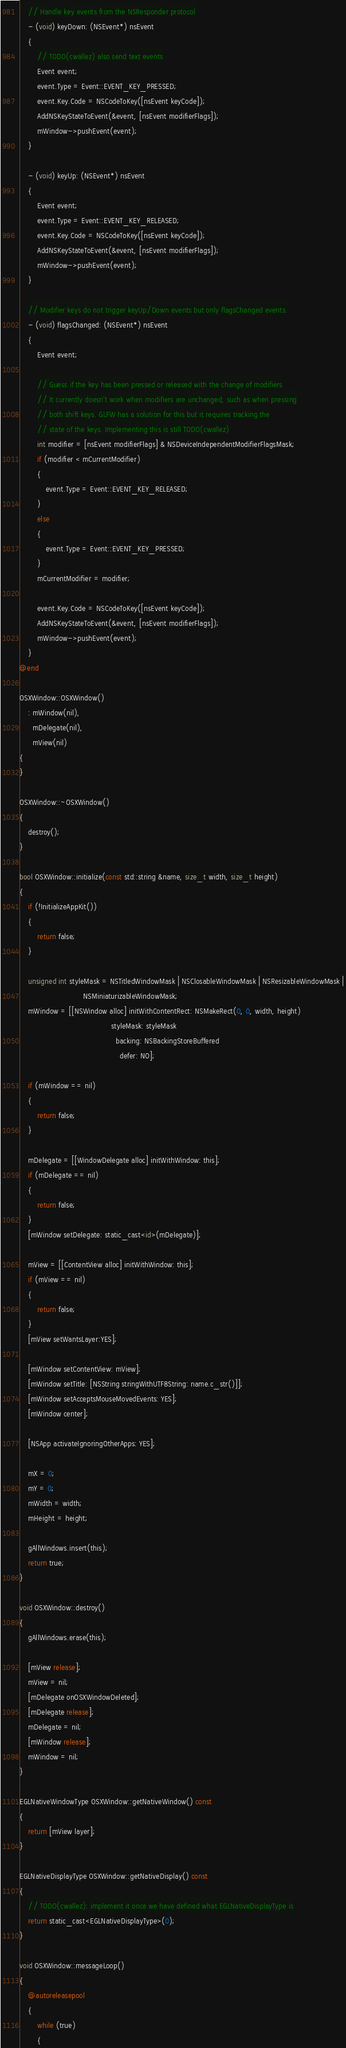Convert code to text. <code><loc_0><loc_0><loc_500><loc_500><_ObjectiveC_>    // Handle key events from the NSResponder protocol
    - (void) keyDown: (NSEvent*) nsEvent
    {
        // TODO(cwallez) also send text events
        Event event;
        event.Type = Event::EVENT_KEY_PRESSED;
        event.Key.Code = NSCodeToKey([nsEvent keyCode]);
        AddNSKeyStateToEvent(&event, [nsEvent modifierFlags]);
        mWindow->pushEvent(event);
    }

    - (void) keyUp: (NSEvent*) nsEvent
    {
        Event event;
        event.Type = Event::EVENT_KEY_RELEASED;
        event.Key.Code = NSCodeToKey([nsEvent keyCode]);
        AddNSKeyStateToEvent(&event, [nsEvent modifierFlags]);
        mWindow->pushEvent(event);
    }

    // Modifier keys do not trigger keyUp/Down events but only flagsChanged events.
    - (void) flagsChanged: (NSEvent*) nsEvent
    {
        Event event;

        // Guess if the key has been pressed or released with the change of modifiers
        // It currently doesn't work when modifiers are unchanged, such as when pressing
        // both shift keys. GLFW has a solution for this but it requires tracking the
        // state of the keys. Implementing this is still TODO(cwallez)
        int modifier = [nsEvent modifierFlags] & NSDeviceIndependentModifierFlagsMask;
        if (modifier < mCurrentModifier)
        {
            event.Type = Event::EVENT_KEY_RELEASED;
        }
        else
        {
            event.Type = Event::EVENT_KEY_PRESSED;
        }
        mCurrentModifier = modifier;

        event.Key.Code = NSCodeToKey([nsEvent keyCode]);
        AddNSKeyStateToEvent(&event, [nsEvent modifierFlags]);
        mWindow->pushEvent(event);
    }
@end

OSXWindow::OSXWindow()
    : mWindow(nil),
      mDelegate(nil),
      mView(nil)
{
}

OSXWindow::~OSXWindow()
{
    destroy();
}

bool OSXWindow::initialize(const std::string &name, size_t width, size_t height)
{
    if (!InitializeAppKit())
    {
        return false;
    }

    unsigned int styleMask = NSTitledWindowMask | NSClosableWindowMask | NSResizableWindowMask |
                             NSMiniaturizableWindowMask;
    mWindow = [[NSWindow alloc] initWithContentRect: NSMakeRect(0, 0, width, height)
                                          styleMask: styleMask
                                            backing: NSBackingStoreBuffered
                                              defer: NO];

    if (mWindow == nil)
    {
        return false;
    }

    mDelegate = [[WindowDelegate alloc] initWithWindow: this];
    if (mDelegate == nil)
    {
        return false;
    }
    [mWindow setDelegate: static_cast<id>(mDelegate)];

    mView = [[ContentView alloc] initWithWindow: this];
    if (mView == nil)
    {
        return false;
    }
    [mView setWantsLayer:YES];

    [mWindow setContentView: mView];
    [mWindow setTitle: [NSString stringWithUTF8String: name.c_str()]];
    [mWindow setAcceptsMouseMovedEvents: YES];
    [mWindow center];

    [NSApp activateIgnoringOtherApps: YES];

    mX = 0;
    mY = 0;
    mWidth = width;
    mHeight = height;

    gAllWindows.insert(this);
    return true;
}

void OSXWindow::destroy()
{
    gAllWindows.erase(this);

    [mView release];
    mView = nil;
    [mDelegate onOSXWindowDeleted];
    [mDelegate release];
    mDelegate = nil;
    [mWindow release];
    mWindow = nil;
}

EGLNativeWindowType OSXWindow::getNativeWindow() const
{
    return [mView layer];
}

EGLNativeDisplayType OSXWindow::getNativeDisplay() const
{
    // TODO(cwallez): implement it once we have defined what EGLNativeDisplayType is
    return static_cast<EGLNativeDisplayType>(0);
}

void OSXWindow::messageLoop()
{
    @autoreleasepool
    {
        while (true)
        {</code> 